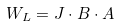<formula> <loc_0><loc_0><loc_500><loc_500>W _ { L } = J \cdot B \cdot A</formula> 